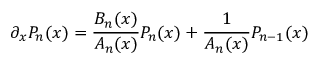<formula> <loc_0><loc_0><loc_500><loc_500>\partial _ { x } P _ { n } ( x ) = \frac { B _ { n } ( x ) } { A _ { n } ( x ) } P _ { n } ( x ) + \frac { 1 } { A _ { n } ( x ) } P _ { n - 1 } ( x )</formula> 